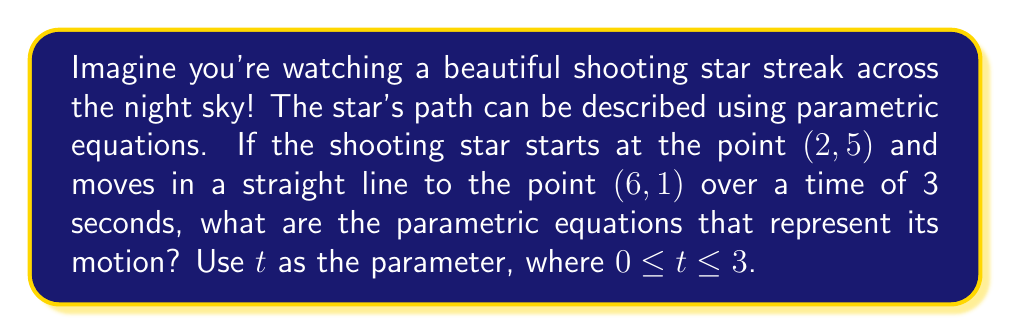Provide a solution to this math problem. Let's break this down step-by-step:

1) First, we need to understand what parametric equations are. They are a set of equations that describe the x and y coordinates of a point in terms of a parameter (in this case, time t).

2) We're given two points:
   Start point: (2, 5)
   End point: (6, 1)

3) We need to find how x and y change over time. Let's call our equations $x(t)$ and $y(t)$.

4) For $x(t)$:
   - It starts at 2 and ends at 6
   - Total change in x = 6 - 2 = 4
   - Rate of change = 4 ÷ 3 = $\frac{4}{3}$ per second

5) For $y(t)$:
   - It starts at 5 and ends at 1
   - Total change in y = 1 - 5 = -4
   - Rate of change = -4 ÷ 3 = $-\frac{4}{3}$ per second

6) Now we can write our equations:

   $x(t) = 2 + \frac{4}{3}t$
   $y(t) = 5 - \frac{4}{3}t$

   Where 2 and 5 are the starting x and y coordinates, and $\frac{4}{3}t$ and $-\frac{4}{3}t$ represent the change over time.

7) These equations work for $0 \leq t \leq 3$, as the shooting star is visible for 3 seconds.
Answer: The parametric equations representing the motion of the shooting star are:

$$x(t) = 2 + \frac{4}{3}t$$
$$y(t) = 5 - \frac{4}{3}t$$

Where $0 \leq t \leq 3$ 